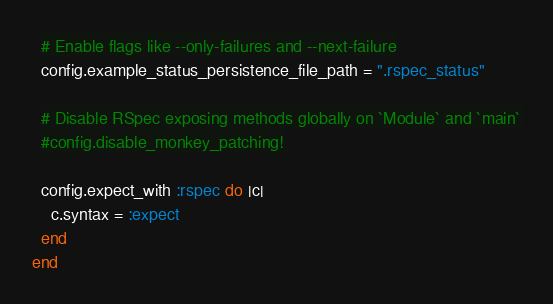Convert code to text. <code><loc_0><loc_0><loc_500><loc_500><_Ruby_>  # Enable flags like --only-failures and --next-failure
  config.example_status_persistence_file_path = ".rspec_status"

  # Disable RSpec exposing methods globally on `Module` and `main`
  #config.disable_monkey_patching!

  config.expect_with :rspec do |c|
    c.syntax = :expect
  end
end
</code> 